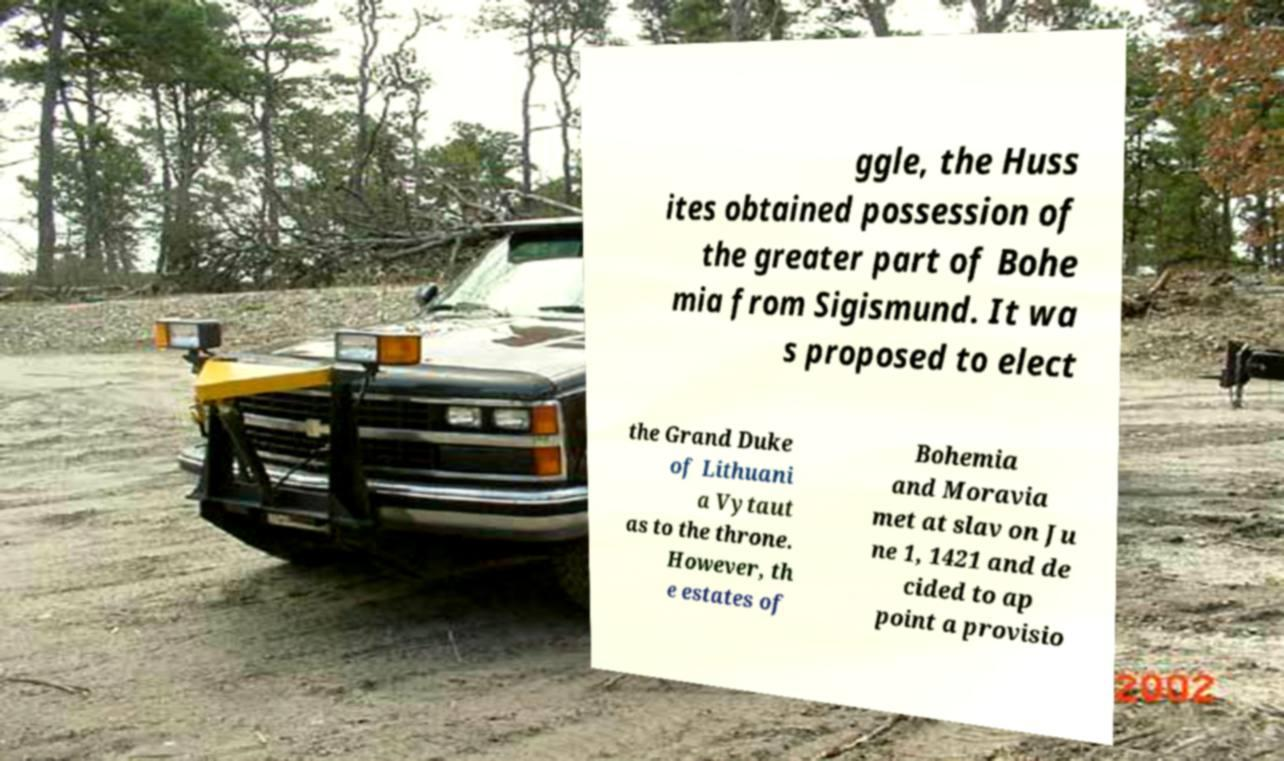Can you accurately transcribe the text from the provided image for me? ggle, the Huss ites obtained possession of the greater part of Bohe mia from Sigismund. It wa s proposed to elect the Grand Duke of Lithuani a Vytaut as to the throne. However, th e estates of Bohemia and Moravia met at slav on Ju ne 1, 1421 and de cided to ap point a provisio 